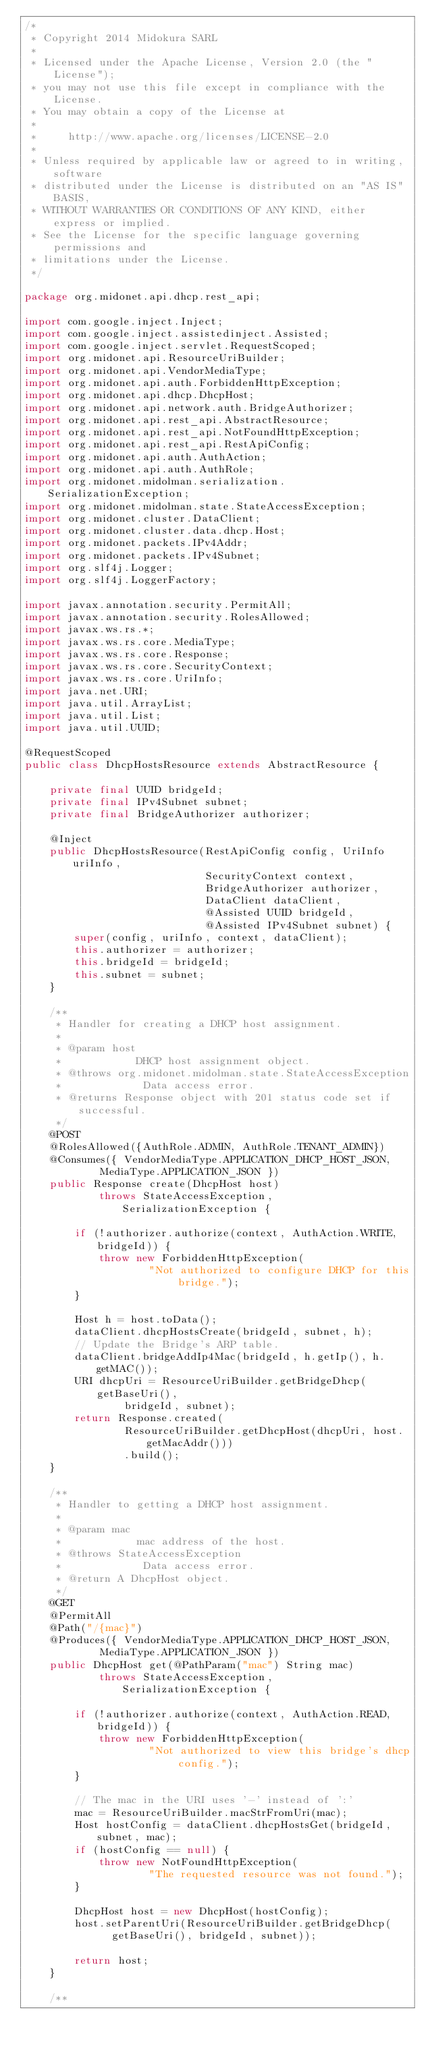Convert code to text. <code><loc_0><loc_0><loc_500><loc_500><_Java_>/*
 * Copyright 2014 Midokura SARL
 *
 * Licensed under the Apache License, Version 2.0 (the "License");
 * you may not use this file except in compliance with the License.
 * You may obtain a copy of the License at
 *
 *     http://www.apache.org/licenses/LICENSE-2.0
 *
 * Unless required by applicable law or agreed to in writing, software
 * distributed under the License is distributed on an "AS IS" BASIS,
 * WITHOUT WARRANTIES OR CONDITIONS OF ANY KIND, either express or implied.
 * See the License for the specific language governing permissions and
 * limitations under the License.
 */

package org.midonet.api.dhcp.rest_api;

import com.google.inject.Inject;
import com.google.inject.assistedinject.Assisted;
import com.google.inject.servlet.RequestScoped;
import org.midonet.api.ResourceUriBuilder;
import org.midonet.api.VendorMediaType;
import org.midonet.api.auth.ForbiddenHttpException;
import org.midonet.api.dhcp.DhcpHost;
import org.midonet.api.network.auth.BridgeAuthorizer;
import org.midonet.api.rest_api.AbstractResource;
import org.midonet.api.rest_api.NotFoundHttpException;
import org.midonet.api.rest_api.RestApiConfig;
import org.midonet.api.auth.AuthAction;
import org.midonet.api.auth.AuthRole;
import org.midonet.midolman.serialization.SerializationException;
import org.midonet.midolman.state.StateAccessException;
import org.midonet.cluster.DataClient;
import org.midonet.cluster.data.dhcp.Host;
import org.midonet.packets.IPv4Addr;
import org.midonet.packets.IPv4Subnet;
import org.slf4j.Logger;
import org.slf4j.LoggerFactory;

import javax.annotation.security.PermitAll;
import javax.annotation.security.RolesAllowed;
import javax.ws.rs.*;
import javax.ws.rs.core.MediaType;
import javax.ws.rs.core.Response;
import javax.ws.rs.core.SecurityContext;
import javax.ws.rs.core.UriInfo;
import java.net.URI;
import java.util.ArrayList;
import java.util.List;
import java.util.UUID;

@RequestScoped
public class DhcpHostsResource extends AbstractResource {

    private final UUID bridgeId;
    private final IPv4Subnet subnet;
    private final BridgeAuthorizer authorizer;

    @Inject
    public DhcpHostsResource(RestApiConfig config, UriInfo uriInfo,
                             SecurityContext context,
                             BridgeAuthorizer authorizer,
                             DataClient dataClient,
                             @Assisted UUID bridgeId,
                             @Assisted IPv4Subnet subnet) {
        super(config, uriInfo, context, dataClient);
        this.authorizer = authorizer;
        this.bridgeId = bridgeId;
        this.subnet = subnet;
    }

    /**
     * Handler for creating a DHCP host assignment.
     *
     * @param host
     *            DHCP host assignment object.
     * @throws org.midonet.midolman.state.StateAccessException
     *             Data access error.
     * @returns Response object with 201 status code set if successful.
     */
    @POST
    @RolesAllowed({AuthRole.ADMIN, AuthRole.TENANT_ADMIN})
    @Consumes({ VendorMediaType.APPLICATION_DHCP_HOST_JSON,
            MediaType.APPLICATION_JSON })
    public Response create(DhcpHost host)
            throws StateAccessException, SerializationException {

        if (!authorizer.authorize(context, AuthAction.WRITE, bridgeId)) {
            throw new ForbiddenHttpException(
                    "Not authorized to configure DHCP for this bridge.");
        }

        Host h = host.toData();
        dataClient.dhcpHostsCreate(bridgeId, subnet, h);
        // Update the Bridge's ARP table.
        dataClient.bridgeAddIp4Mac(bridgeId, h.getIp(), h.getMAC());
        URI dhcpUri = ResourceUriBuilder.getBridgeDhcp(getBaseUri(),
                bridgeId, subnet);
        return Response.created(
                ResourceUriBuilder.getDhcpHost(dhcpUri, host.getMacAddr()))
                .build();
    }

    /**
     * Handler to getting a DHCP host assignment.
     *
     * @param mac
     *            mac address of the host.
     * @throws StateAccessException
     *             Data access error.
     * @return A DhcpHost object.
     */
    @GET
    @PermitAll
    @Path("/{mac}")
    @Produces({ VendorMediaType.APPLICATION_DHCP_HOST_JSON,
            MediaType.APPLICATION_JSON })
    public DhcpHost get(@PathParam("mac") String mac)
            throws StateAccessException, SerializationException {

        if (!authorizer.authorize(context, AuthAction.READ, bridgeId)) {
            throw new ForbiddenHttpException(
                    "Not authorized to view this bridge's dhcp config.");
        }

        // The mac in the URI uses '-' instead of ':'
        mac = ResourceUriBuilder.macStrFromUri(mac);
        Host hostConfig = dataClient.dhcpHostsGet(bridgeId, subnet, mac);
        if (hostConfig == null) {
            throw new NotFoundHttpException(
                    "The requested resource was not found.");
        }

        DhcpHost host = new DhcpHost(hostConfig);
        host.setParentUri(ResourceUriBuilder.getBridgeDhcp(
              getBaseUri(), bridgeId, subnet));

        return host;
    }

    /**</code> 